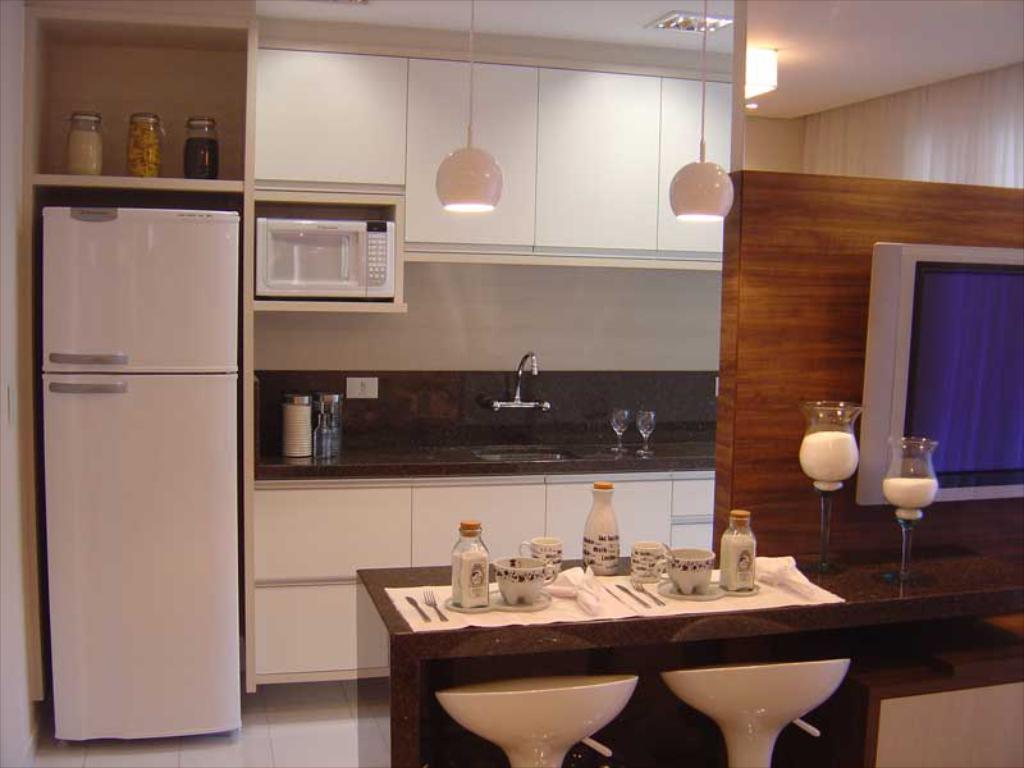Could you give a brief overview of what you see in this image? In the center of the image there is a table on which there are cups,knife,fork spoons. There are glasses. There are chairs. In the background of the image there is a sink. There is a refrigerator. There are cupboards. There are lights. To the right side of the image there is a TV. At the top of the image there is ceiling. 